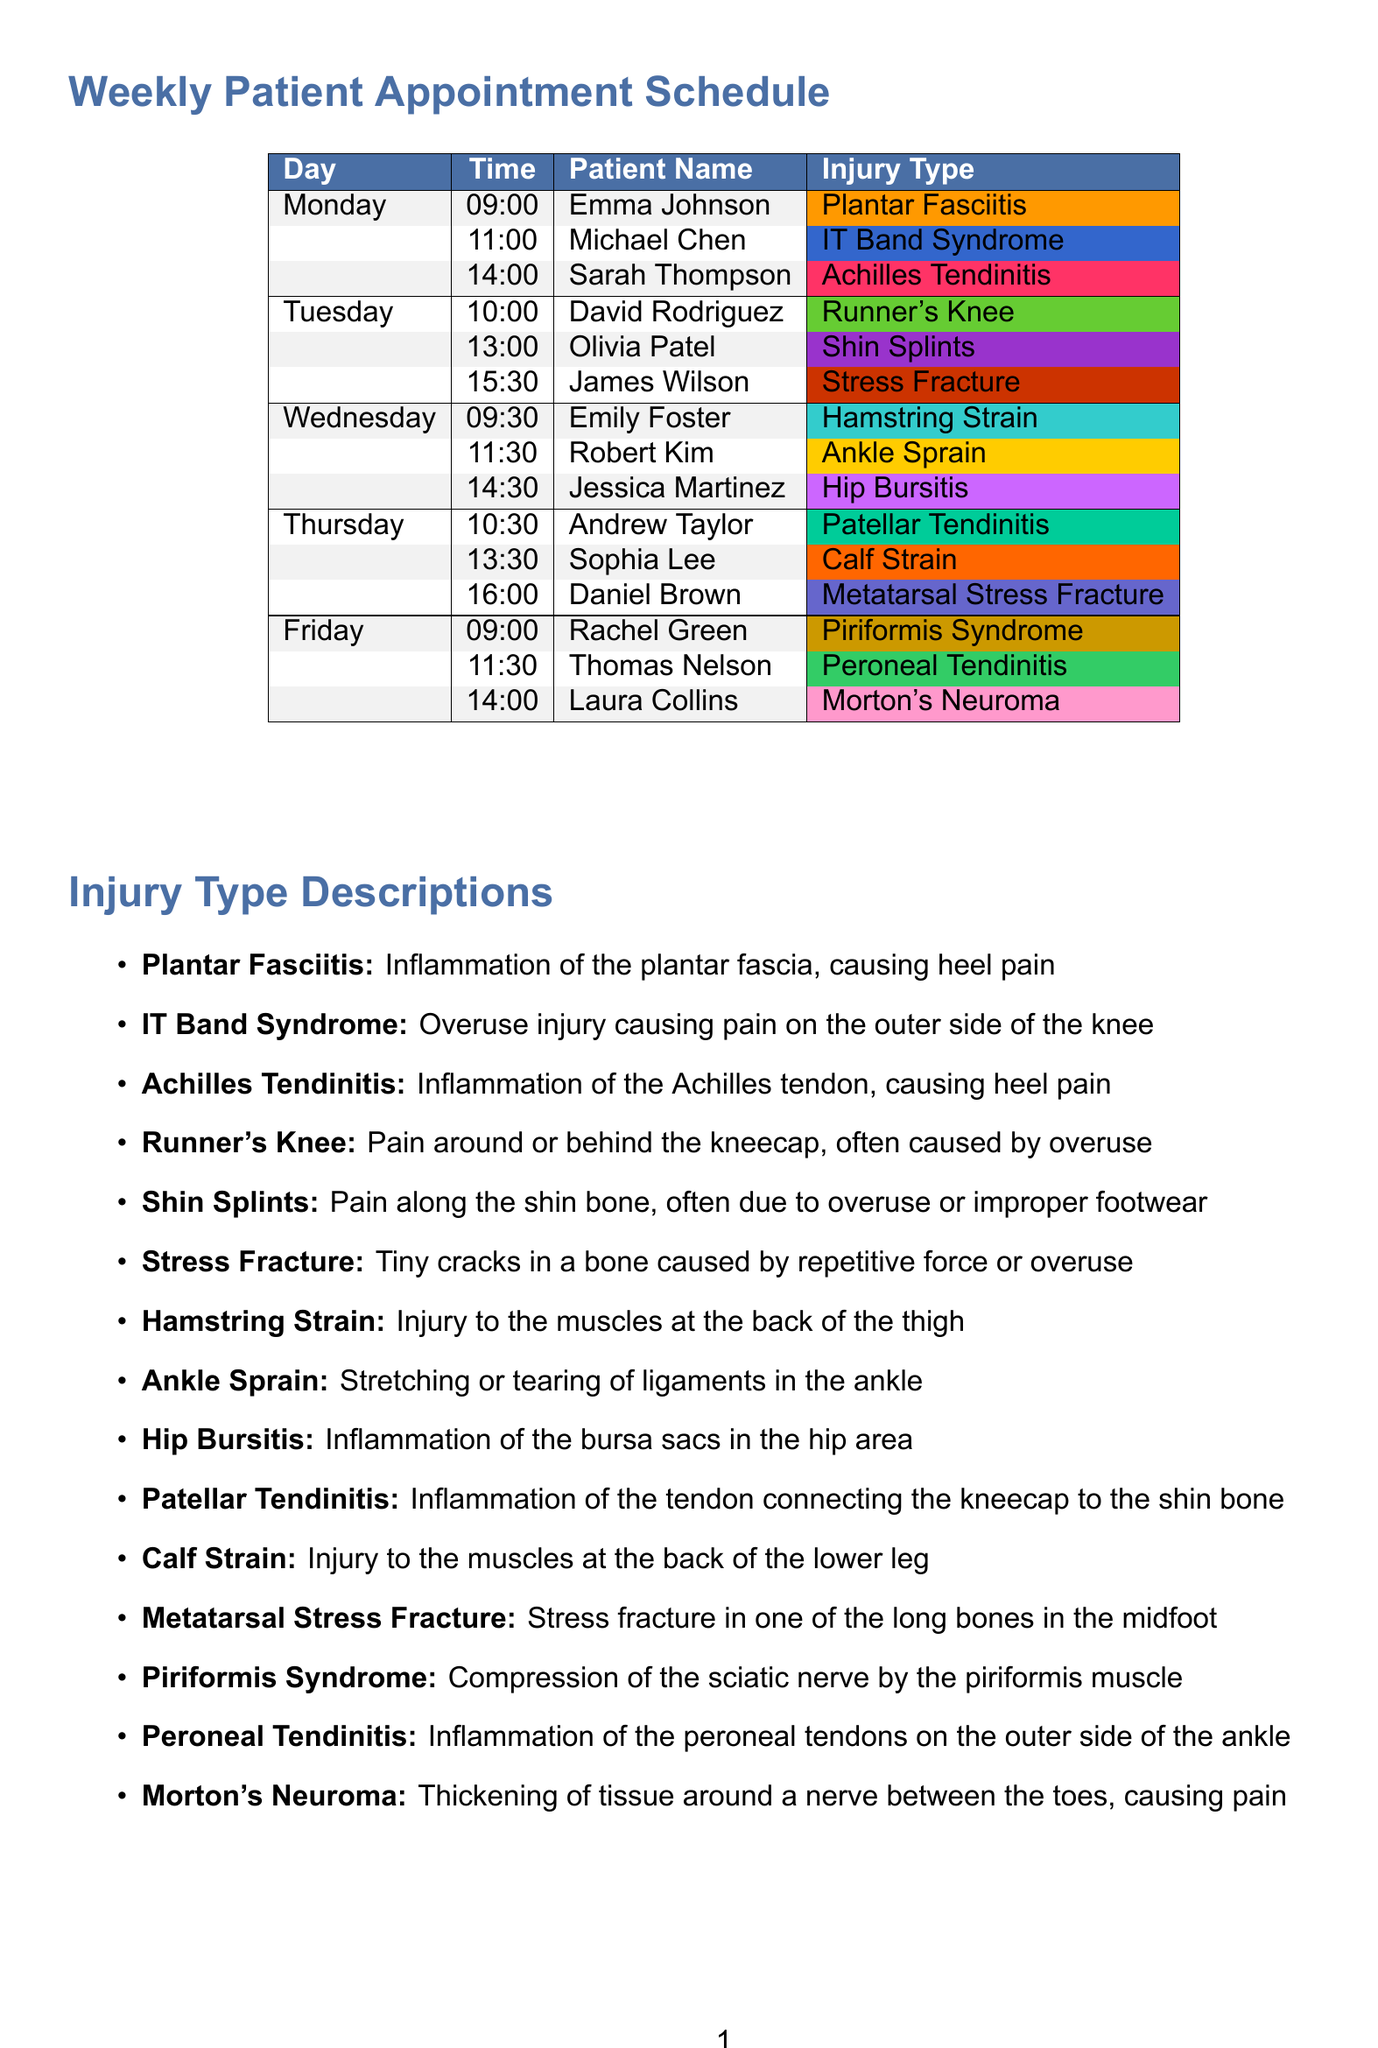What is the injury type for Emma Johnson? Emma Johnson's appointment on Monday at 09:00 is for Plantar Fasciitis.
Answer: Plantar Fasciitis How many appointments are scheduled on Tuesday? There are three appointments listed for Tuesday.
Answer: 3 What time is Rachel Green's appointment? Rachel Green's appointment is scheduled for Friday at 09:00.
Answer: 09:00 Which patient has an appointment for a Stress Fracture? James Wilson is the patient scheduled for a Stress Fracture on Tuesday at 15:30.
Answer: James Wilson What color code represents Calf Strain? The color code for Calf Strain, scheduled on Thursday, is #FF6600.
Answer: #FF6600 Which injury type is associated with inflammation of the peroneal tendons? This injury type is Peroneal Tendinitis, mentioned in the document.
Answer: Peroneal Tendinitis How many days are appointments scheduled? Appointments are scheduled for five days throughout the week.
Answer: 5 What is a common treatment method listed in the document? Several treatment methods are provided, such as Rest and Ice.
Answer: Rest and Ice What time is Sarah Thompson's appointment? Sarah Thompson's appointment is on Monday at 14:00.
Answer: 14:00 